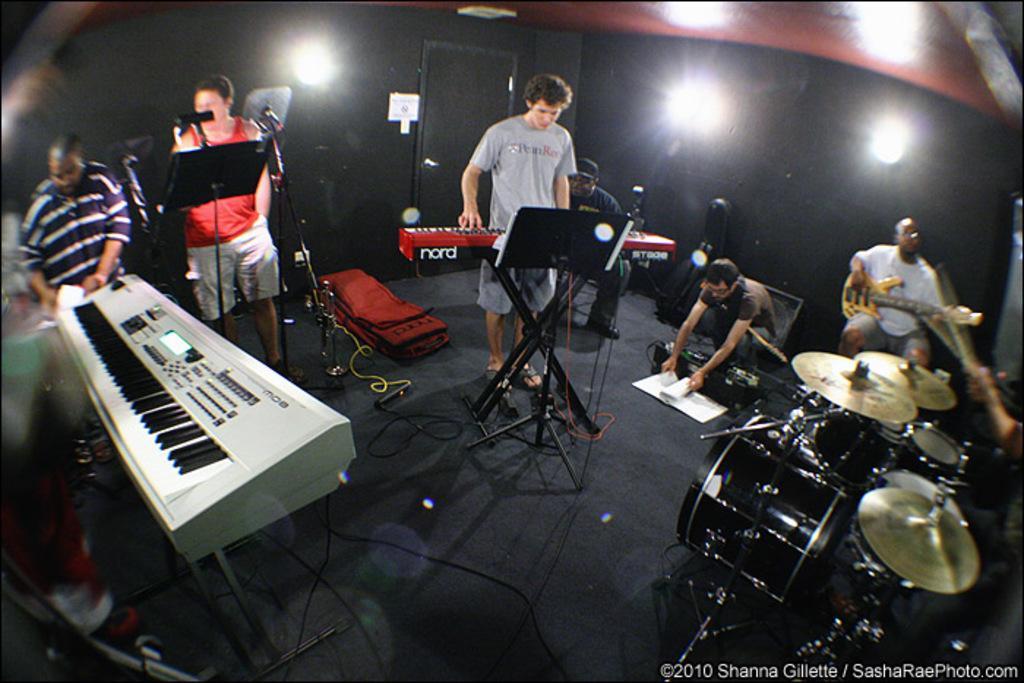Could you give a brief overview of what you see in this image? It is taken in a closed room where number of people sitting and standing and coming to the right corner of the picture one person is sitting and laying a guitar in white shirt and in front of him there are drums and coming to the left corner of the picture one person is standing and taking some papers and beside him on person is wearing a white t-shirt is standing and there are some wires and bags and books are on the floor and in the middle of the picture one person is standing in a grey dress and playing the keyboard and behind him there is a big door in black colour and walls are in black colour and the roof is in red colour and one person is sitting wearing a cap and black dress. 